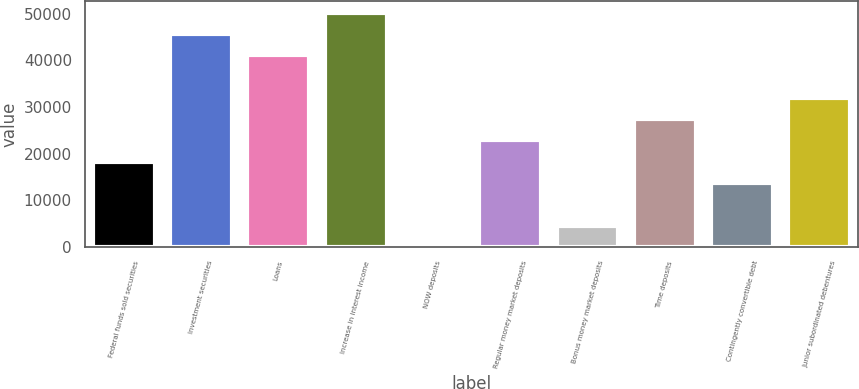<chart> <loc_0><loc_0><loc_500><loc_500><bar_chart><fcel>Federal funds sold securities<fcel>Investment securities<fcel>Loans<fcel>Increase in interest income<fcel>NOW deposits<fcel>Regular money market deposits<fcel>Bonus money market deposits<fcel>Time deposits<fcel>Contingently convertible debt<fcel>Junior subordinated debentures<nl><fcel>18272.6<fcel>45668<fcel>41102.1<fcel>50233.9<fcel>9<fcel>22838.5<fcel>4574.9<fcel>27404.4<fcel>13706.7<fcel>31970.3<nl></chart> 